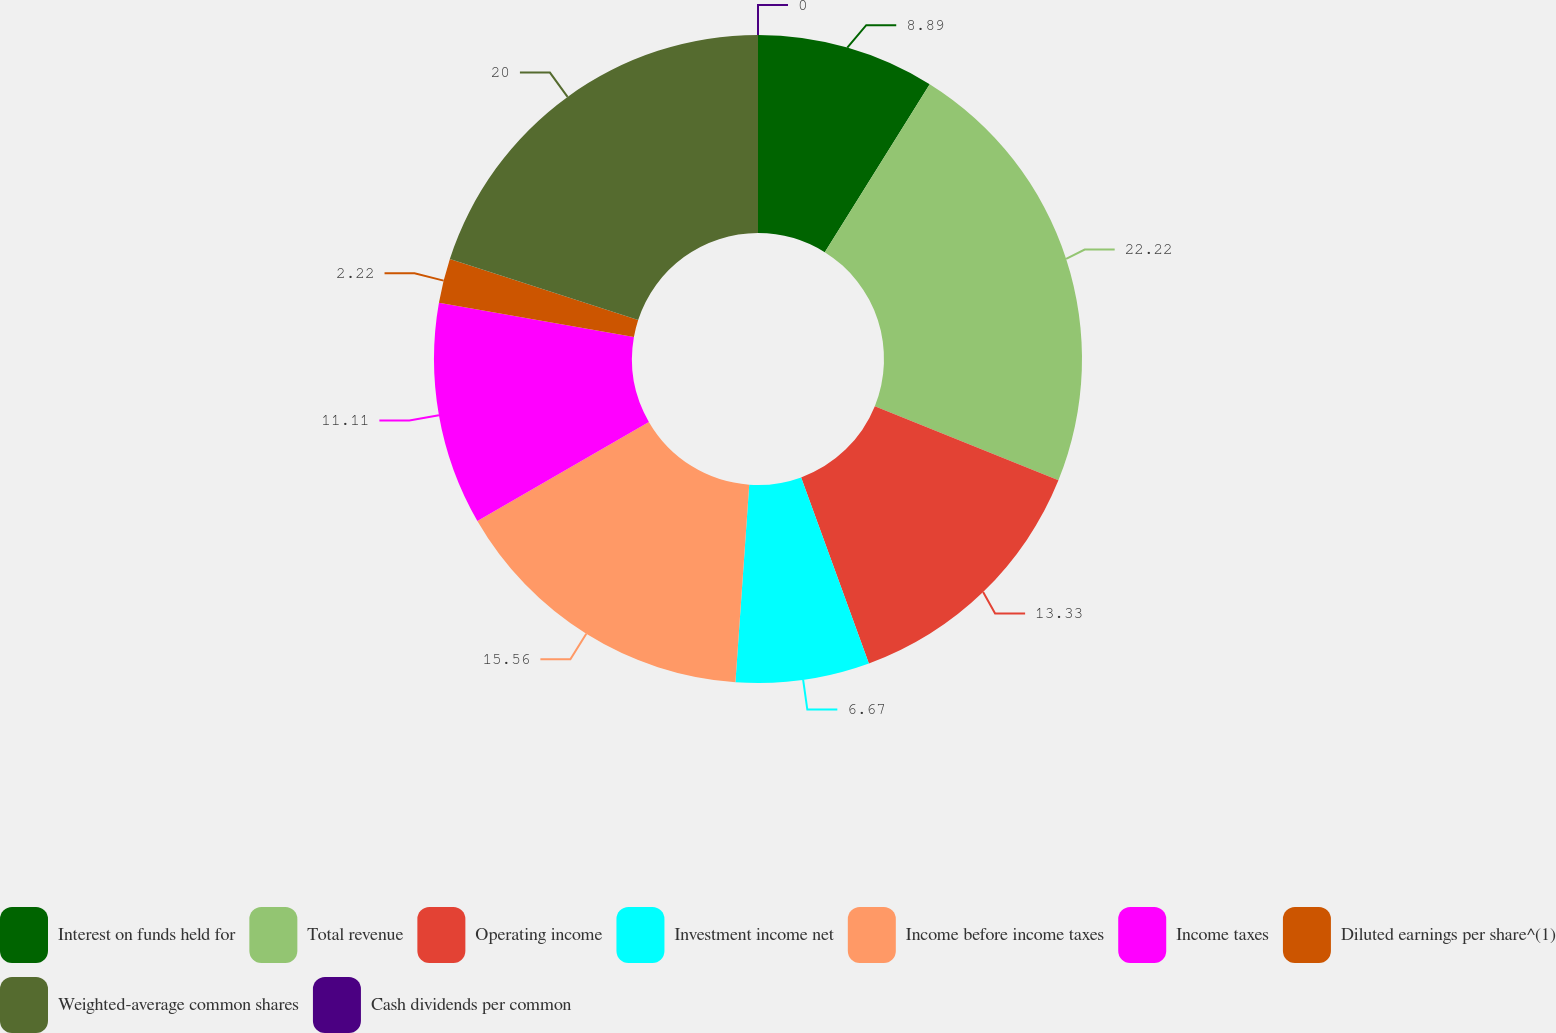Convert chart. <chart><loc_0><loc_0><loc_500><loc_500><pie_chart><fcel>Interest on funds held for<fcel>Total revenue<fcel>Operating income<fcel>Investment income net<fcel>Income before income taxes<fcel>Income taxes<fcel>Diluted earnings per share^(1)<fcel>Weighted-average common shares<fcel>Cash dividends per common<nl><fcel>8.89%<fcel>22.22%<fcel>13.33%<fcel>6.67%<fcel>15.56%<fcel>11.11%<fcel>2.22%<fcel>20.0%<fcel>0.0%<nl></chart> 